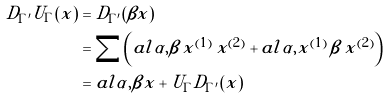<formula> <loc_0><loc_0><loc_500><loc_500>D _ { \Gamma ^ { \prime } } U _ { \Gamma } ( x ) & = D _ { \Gamma ^ { \prime } } ( \beta x ) \\ & = \sum \left ( a l { \alpha , \beta \, x ^ { ( 1 ) } } \, x ^ { ( 2 ) } + a l { \alpha , x ^ { ( 1 ) } } \, \beta \, x ^ { ( 2 ) } \right ) \\ & = a l { \alpha , \beta } x + U _ { \Gamma } D _ { \Gamma ^ { \prime } } ( x )</formula> 